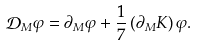<formula> <loc_0><loc_0><loc_500><loc_500>\mathcal { D } _ { M } \varphi = \partial _ { M } \varphi + \frac { 1 } { 7 } \left ( \partial _ { M } K \right ) \varphi .</formula> 